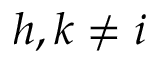<formula> <loc_0><loc_0><loc_500><loc_500>h , k \ne i</formula> 